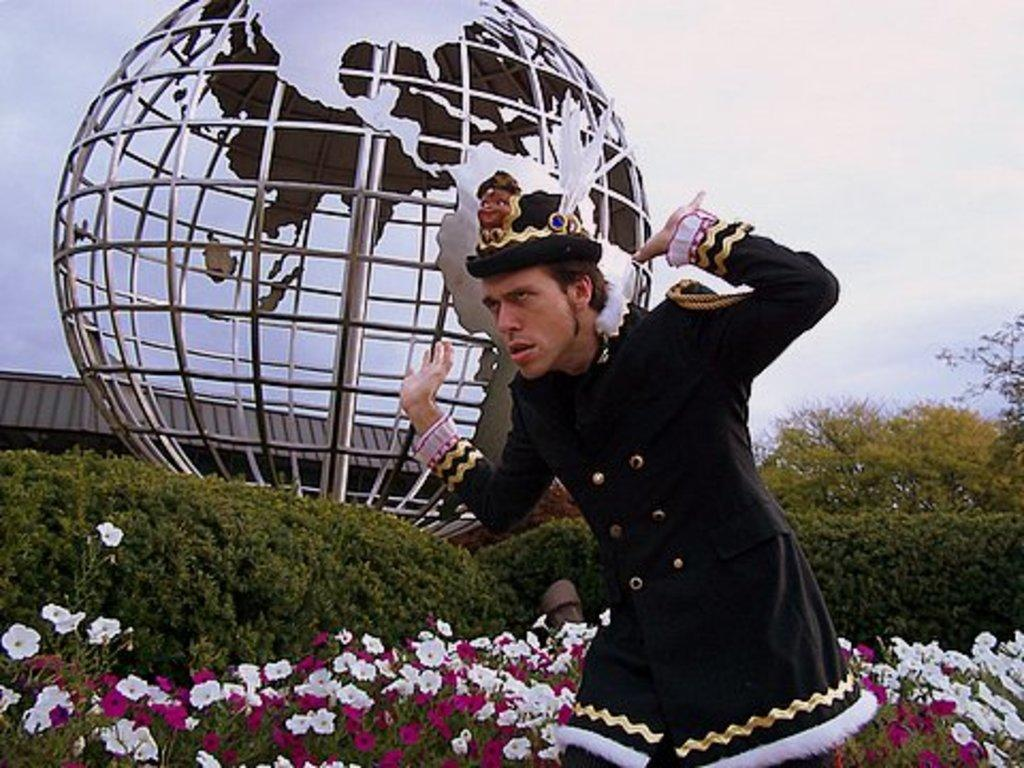What is the main subject of the image? The main subject of the image is a man. How is the man depicted in the image? The man is giving a different expression and pose in the image. What can be seen in the background of the image? There are flower plants, trees, and a sculpture of a globe in the background of the image. What flavor of ice cream is the man holding in the image? There is no ice cream present in the image; the main subject is a man giving a different expression and pose. 